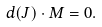<formula> <loc_0><loc_0><loc_500><loc_500>d ( J ) \cdot M = 0 .</formula> 